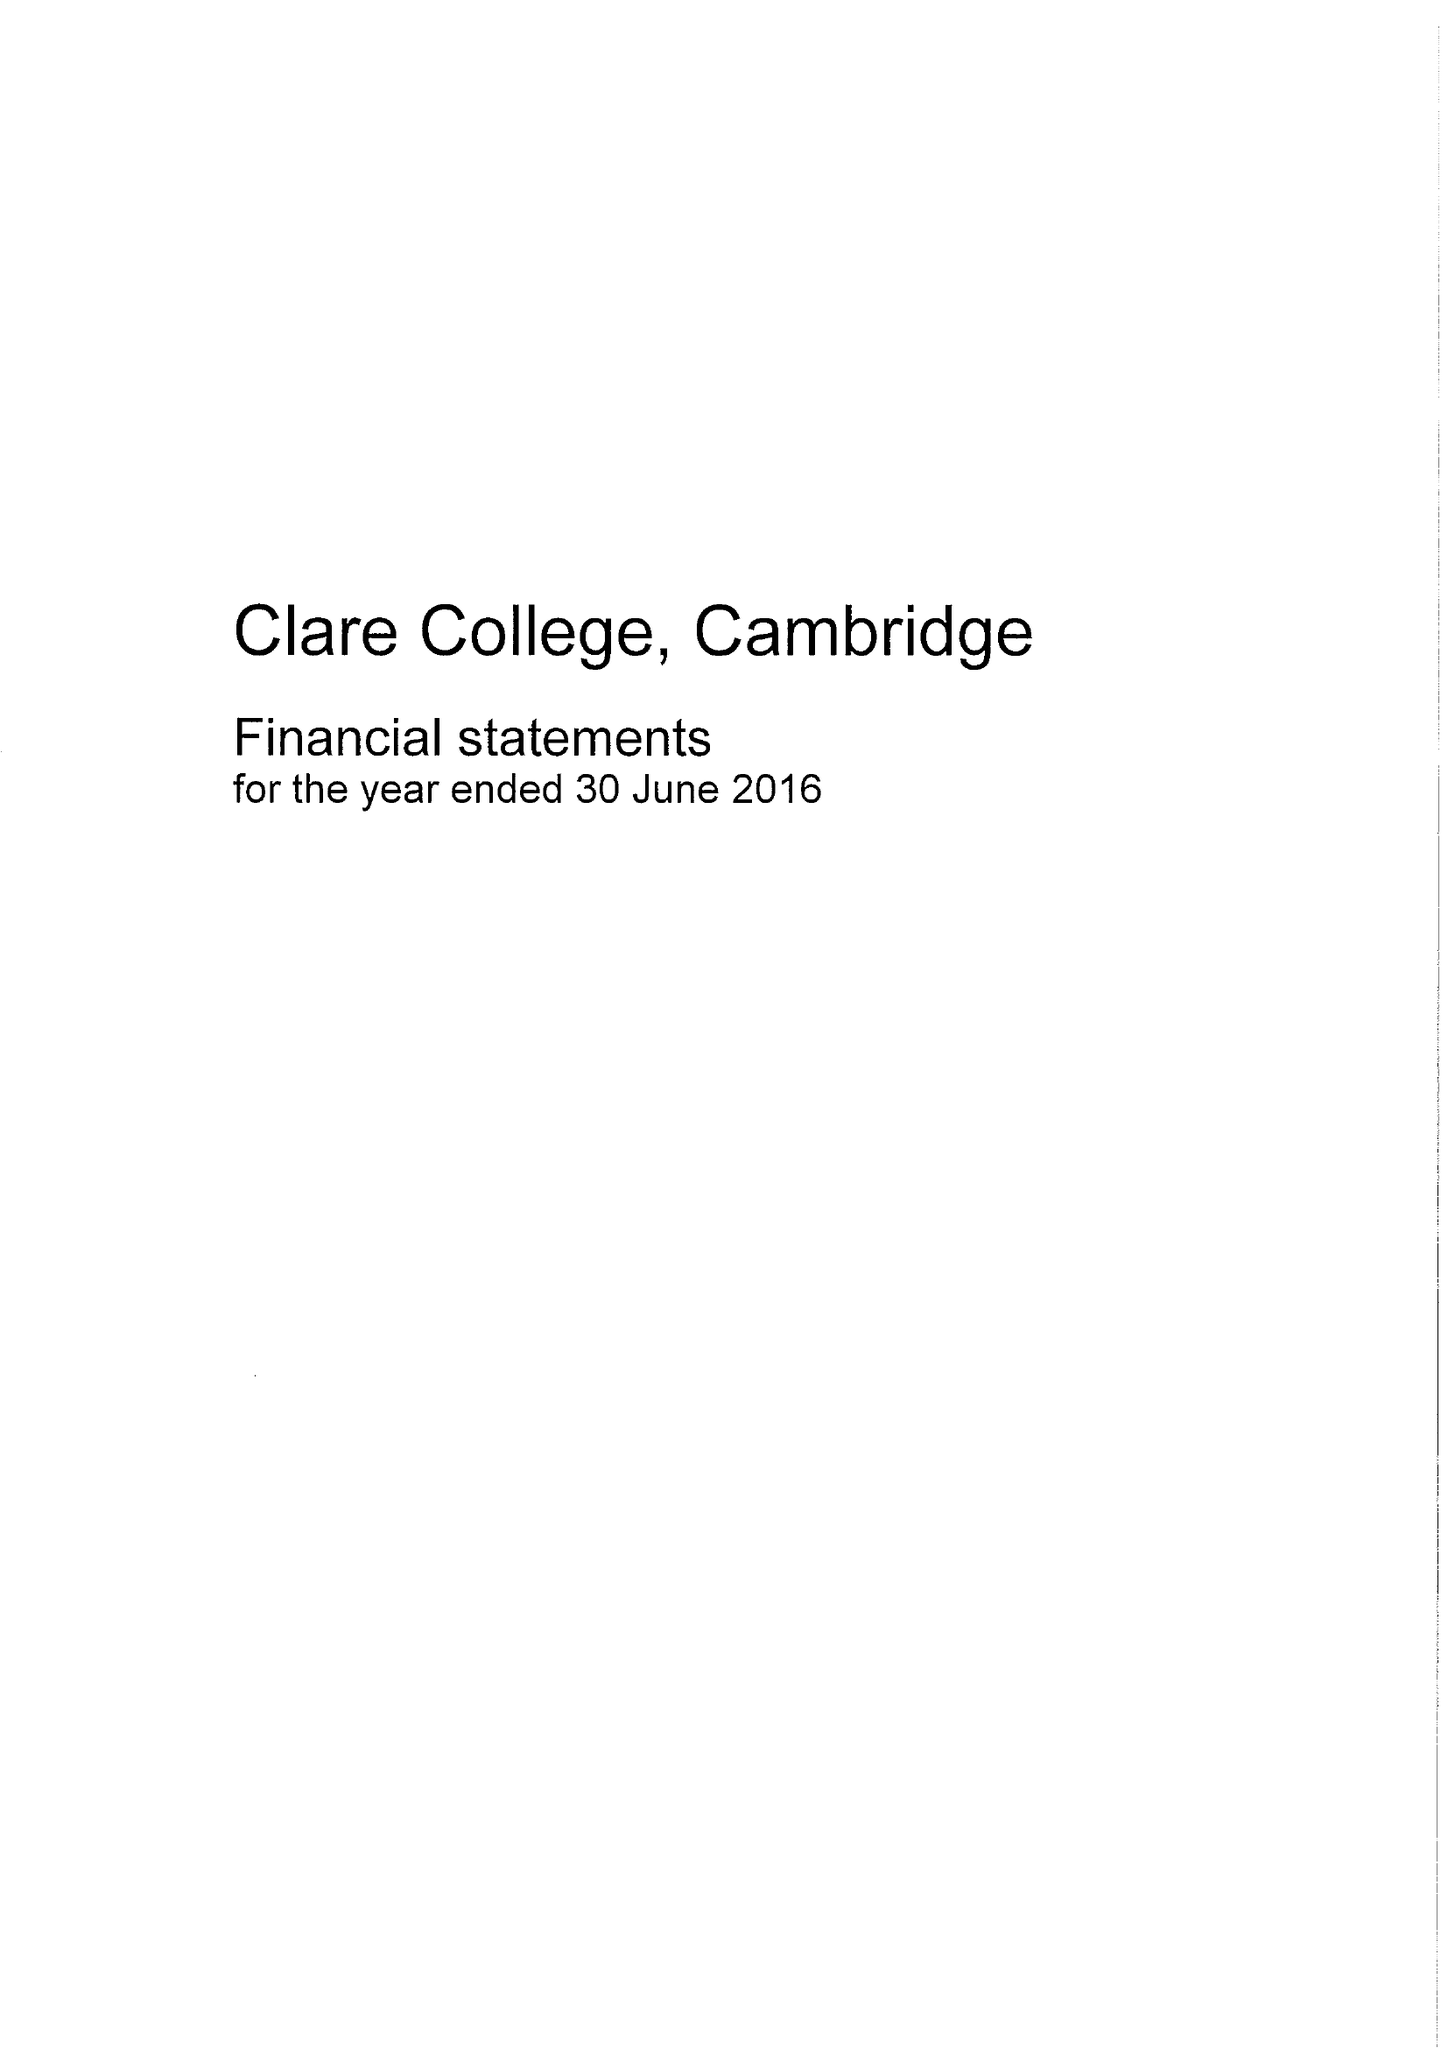What is the value for the spending_annually_in_british_pounds?
Answer the question using a single word or phrase. 13087000.00 